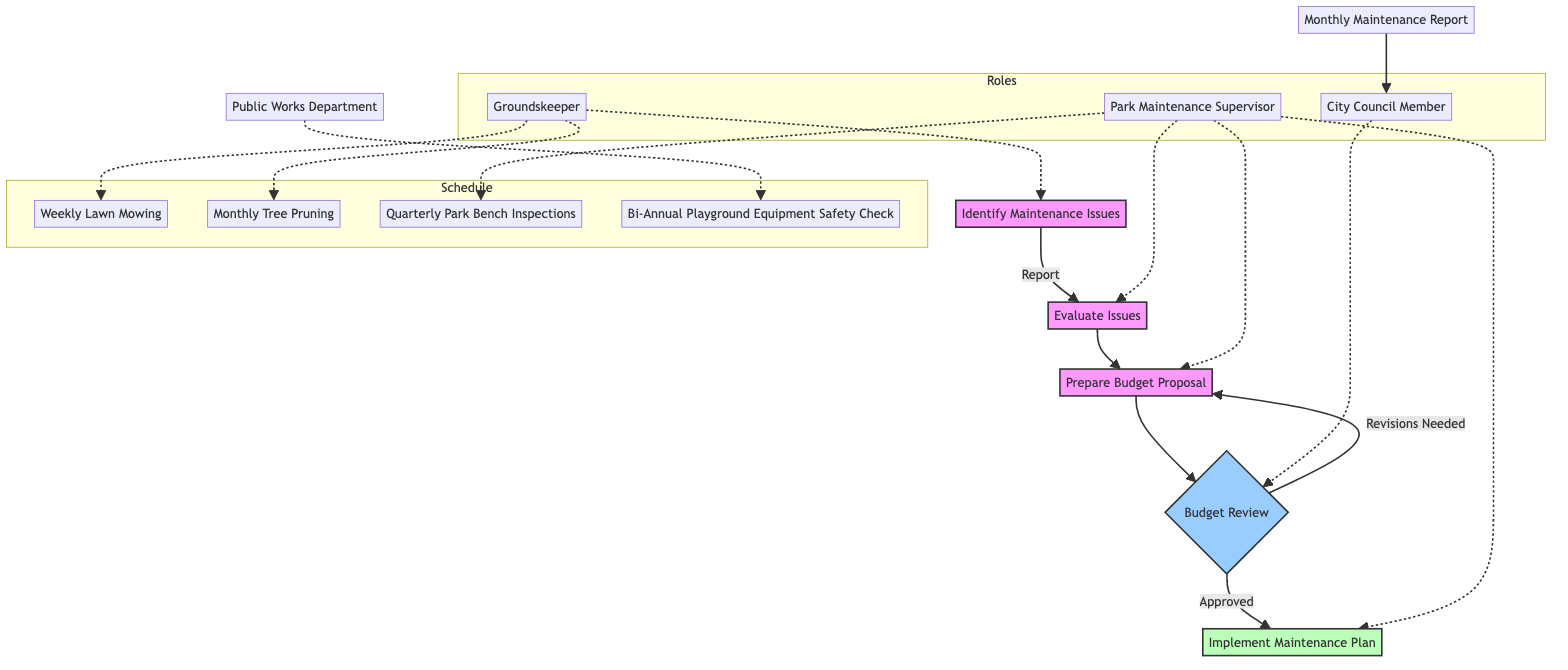What role is responsible for preparing the budget proposal? The Park Maintenance Supervisor is responsible for preparing the budget proposal as indicated in the "Prepare Budget Proposal" step of the diagram.
Answer: Park Maintenance Supervisor How many maintenance tasks are listed in the schedule? There are four maintenance tasks listed in the schedule: Weekly Lawn Mowing, Monthly Tree Pruning, Quarterly Park Bench Inspections, and Bi-Annual Playground Equipment Safety Check.
Answer: Four Who submits the monthly maintenance report? The Park Maintenance Supervisor submits the monthly maintenance report to the City Council Member, as shown in the "reporting" section of the schedule.
Answer: Park Maintenance Supervisor What happens if the budget proposal needs revisions? If the budget proposal needs revisions, the process loops back to the "Prepare Budget Proposal" step for adjustments, as depicted by the arrow indicating a revision required.
Answer: Prepare Budget Proposal Which role evaluates the maintenance issues? The Park Maintenance Supervisor evaluates the maintenance issues, as indicated in the "Evaluate Issues" step of the decision-making process.
Answer: Park Maintenance Supervisor What action does the Groundskeeper take upon identifying maintenance issues? The Groundskeeper reports the maintenance issues to the Park Maintenance Supervisor, as described in the "Identify Maintenance Issues" step.
Answer: Report issues What type of check is performed bi-annually? A Playground Equipment Safety Check is performed bi-annually, as specified in the maintenance schedule.
Answer: Playground Equipment Safety Check How does the City Council Member influence the maintenance process? The City Council Member influences the maintenance process by reviewing and either approving or requesting revisions to the budget proposal. This is key in ensuring necessary funds for maintenance activities.
Answer: Review and approve budget What happens after the budget proposal is approved? After the budget proposal is approved, the next step is to "Implement Maintenance Plan," which involves coordinating and overseeing maintenance tasks.
Answer: Implement Maintenance Plan 